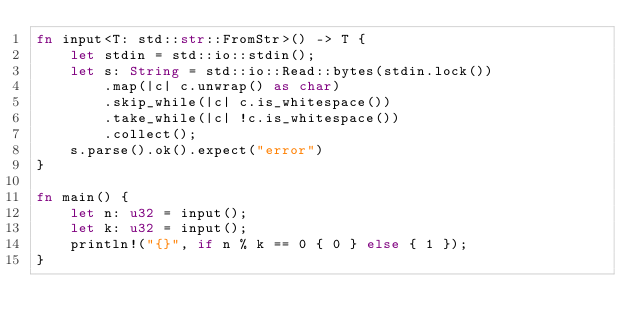Convert code to text. <code><loc_0><loc_0><loc_500><loc_500><_Rust_>fn input<T: std::str::FromStr>() -> T {
    let stdin = std::io::stdin();
    let s: String = std::io::Read::bytes(stdin.lock())
        .map(|c| c.unwrap() as char)
        .skip_while(|c| c.is_whitespace())
        .take_while(|c| !c.is_whitespace())
        .collect();
    s.parse().ok().expect("error")
}

fn main() {
    let n: u32 = input();
    let k: u32 = input();
    println!("{}", if n % k == 0 { 0 } else { 1 });
}</code> 